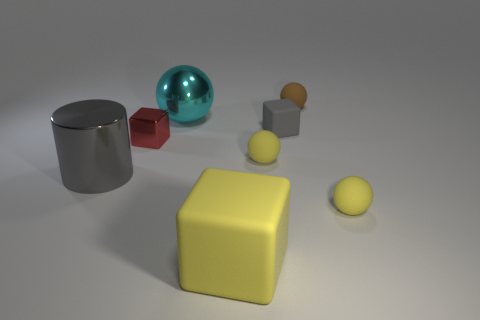What is the small brown thing made of?
Offer a very short reply. Rubber. What number of things are red metallic objects or small brown things?
Your answer should be compact. 2. Is the number of yellow matte balls on the left side of the tiny rubber cube greater than the number of large metallic objects in front of the yellow rubber cube?
Offer a very short reply. Yes. There is a block that is to the right of the yellow rubber block; is its color the same as the object on the left side of the tiny metallic block?
Offer a very short reply. Yes. There is a matte block that is to the right of the large rubber cube that is left of the gray object that is behind the big gray object; what size is it?
Provide a short and direct response. Small. There is a large metal thing that is the same shape as the small brown object; what color is it?
Provide a short and direct response. Cyan. Is the number of large things that are right of the red metal cube greater than the number of brown spheres?
Your response must be concise. Yes. There is a big rubber thing; is it the same shape as the tiny matte thing that is behind the big cyan ball?
Offer a terse response. No. There is a gray matte thing that is the same shape as the red object; what is its size?
Provide a short and direct response. Small. Are there more tiny metallic objects than yellow rubber things?
Make the answer very short. No. 